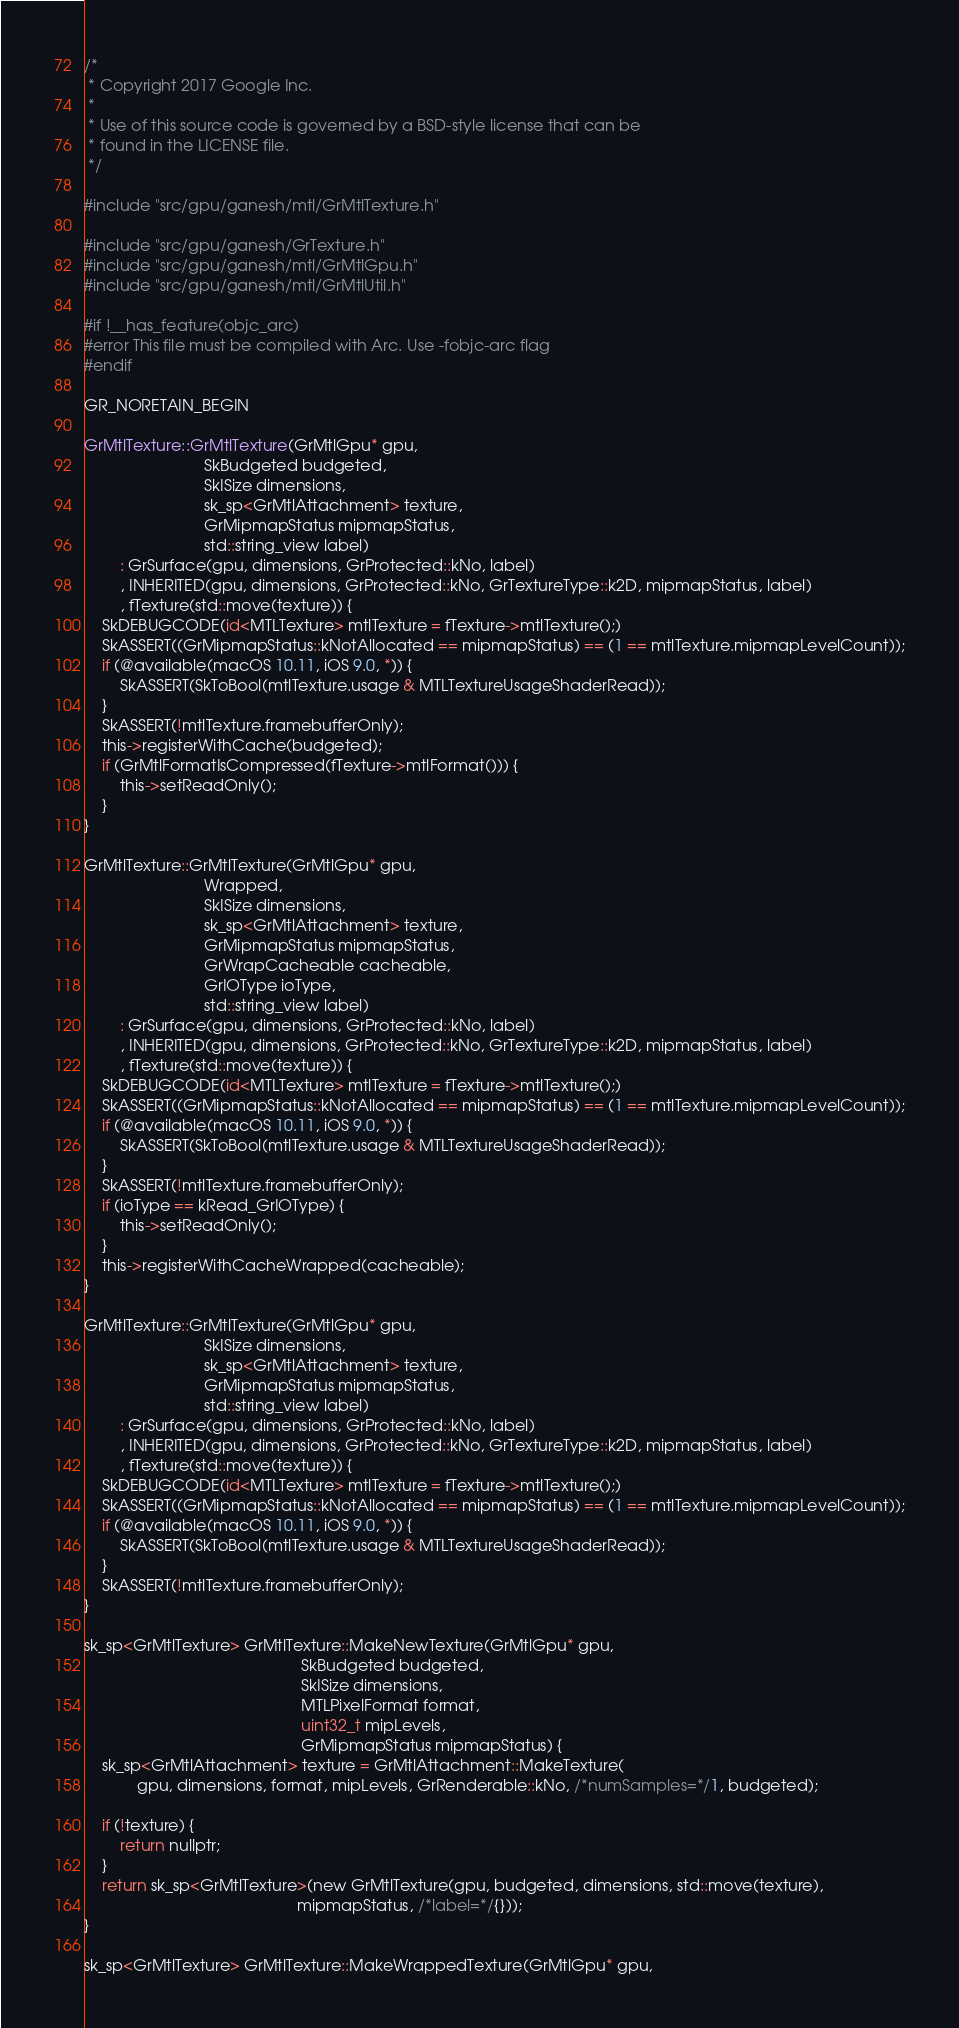Convert code to text. <code><loc_0><loc_0><loc_500><loc_500><_ObjectiveC_>/*
 * Copyright 2017 Google Inc.
 *
 * Use of this source code is governed by a BSD-style license that can be
 * found in the LICENSE file.
 */

#include "src/gpu/ganesh/mtl/GrMtlTexture.h"

#include "src/gpu/ganesh/GrTexture.h"
#include "src/gpu/ganesh/mtl/GrMtlGpu.h"
#include "src/gpu/ganesh/mtl/GrMtlUtil.h"

#if !__has_feature(objc_arc)
#error This file must be compiled with Arc. Use -fobjc-arc flag
#endif

GR_NORETAIN_BEGIN

GrMtlTexture::GrMtlTexture(GrMtlGpu* gpu,
                           SkBudgeted budgeted,
                           SkISize dimensions,
                           sk_sp<GrMtlAttachment> texture,
                           GrMipmapStatus mipmapStatus,
                           std::string_view label)
        : GrSurface(gpu, dimensions, GrProtected::kNo, label)
        , INHERITED(gpu, dimensions, GrProtected::kNo, GrTextureType::k2D, mipmapStatus, label)
        , fTexture(std::move(texture)) {
    SkDEBUGCODE(id<MTLTexture> mtlTexture = fTexture->mtlTexture();)
    SkASSERT((GrMipmapStatus::kNotAllocated == mipmapStatus) == (1 == mtlTexture.mipmapLevelCount));
    if (@available(macOS 10.11, iOS 9.0, *)) {
        SkASSERT(SkToBool(mtlTexture.usage & MTLTextureUsageShaderRead));
    }
    SkASSERT(!mtlTexture.framebufferOnly);
    this->registerWithCache(budgeted);
    if (GrMtlFormatIsCompressed(fTexture->mtlFormat())) {
        this->setReadOnly();
    }
}

GrMtlTexture::GrMtlTexture(GrMtlGpu* gpu,
                           Wrapped,
                           SkISize dimensions,
                           sk_sp<GrMtlAttachment> texture,
                           GrMipmapStatus mipmapStatus,
                           GrWrapCacheable cacheable,
                           GrIOType ioType,
                           std::string_view label)
        : GrSurface(gpu, dimensions, GrProtected::kNo, label)
        , INHERITED(gpu, dimensions, GrProtected::kNo, GrTextureType::k2D, mipmapStatus, label)
        , fTexture(std::move(texture)) {
    SkDEBUGCODE(id<MTLTexture> mtlTexture = fTexture->mtlTexture();)
    SkASSERT((GrMipmapStatus::kNotAllocated == mipmapStatus) == (1 == mtlTexture.mipmapLevelCount));
    if (@available(macOS 10.11, iOS 9.0, *)) {
        SkASSERT(SkToBool(mtlTexture.usage & MTLTextureUsageShaderRead));
    }
    SkASSERT(!mtlTexture.framebufferOnly);
    if (ioType == kRead_GrIOType) {
        this->setReadOnly();
    }
    this->registerWithCacheWrapped(cacheable);
}

GrMtlTexture::GrMtlTexture(GrMtlGpu* gpu,
                           SkISize dimensions,
                           sk_sp<GrMtlAttachment> texture,
                           GrMipmapStatus mipmapStatus,
                           std::string_view label)
        : GrSurface(gpu, dimensions, GrProtected::kNo, label)
        , INHERITED(gpu, dimensions, GrProtected::kNo, GrTextureType::k2D, mipmapStatus, label)
        , fTexture(std::move(texture)) {
    SkDEBUGCODE(id<MTLTexture> mtlTexture = fTexture->mtlTexture();)
    SkASSERT((GrMipmapStatus::kNotAllocated == mipmapStatus) == (1 == mtlTexture.mipmapLevelCount));
    if (@available(macOS 10.11, iOS 9.0, *)) {
        SkASSERT(SkToBool(mtlTexture.usage & MTLTextureUsageShaderRead));
    }
    SkASSERT(!mtlTexture.framebufferOnly);
}

sk_sp<GrMtlTexture> GrMtlTexture::MakeNewTexture(GrMtlGpu* gpu,
                                                 SkBudgeted budgeted,
                                                 SkISize dimensions,
                                                 MTLPixelFormat format,
                                                 uint32_t mipLevels,
                                                 GrMipmapStatus mipmapStatus) {
    sk_sp<GrMtlAttachment> texture = GrMtlAttachment::MakeTexture(
            gpu, dimensions, format, mipLevels, GrRenderable::kNo, /*numSamples=*/1, budgeted);

    if (!texture) {
        return nullptr;
    }
    return sk_sp<GrMtlTexture>(new GrMtlTexture(gpu, budgeted, dimensions, std::move(texture),
                                                mipmapStatus, /*label=*/{}));
}

sk_sp<GrMtlTexture> GrMtlTexture::MakeWrappedTexture(GrMtlGpu* gpu,</code> 